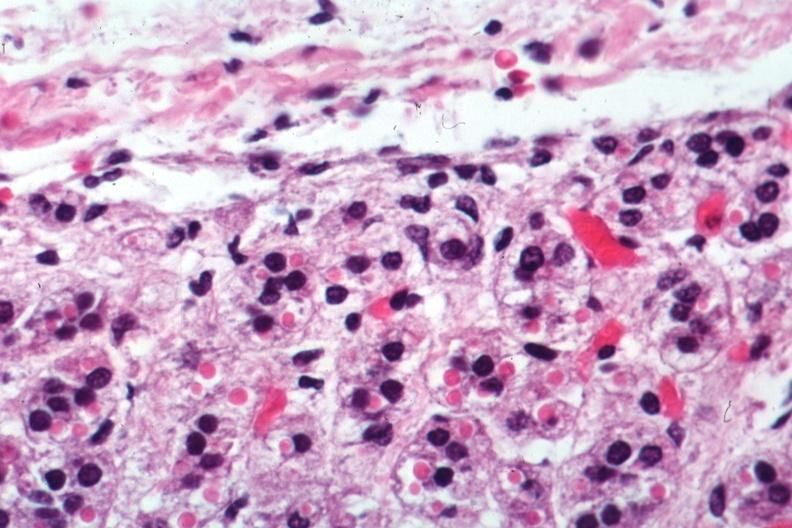where is this part in the figure?
Answer the question using a single word or phrase. Endocrine system 